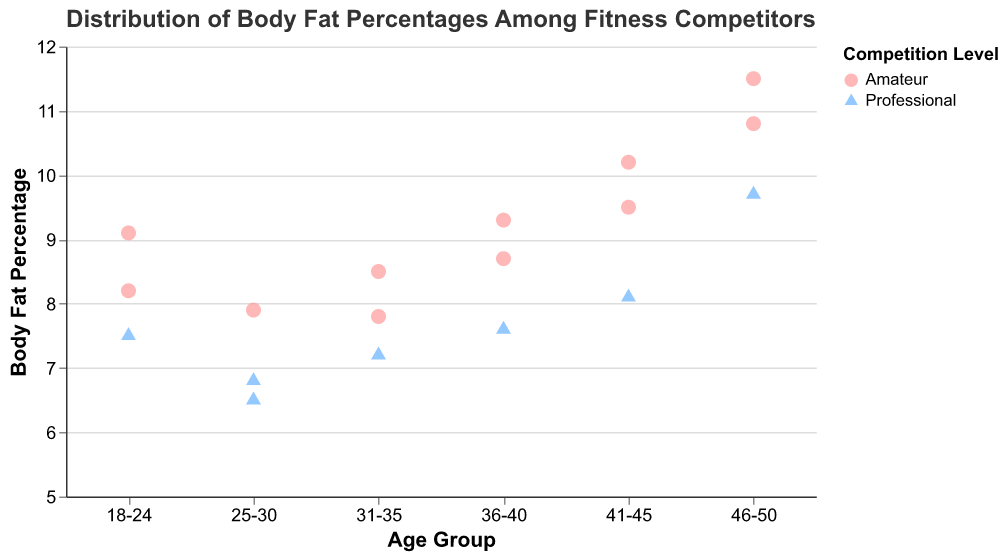What is the title of the figure? The title is usually at the top of the figure and typically in larger font size. Here, it is "Distribution of Body Fat Percentages Among Fitness Competitors."
Answer: Distribution of Body Fat Percentages Among Fitness Competitors What are the age groups present in the figure? The x-axis represents age groups. We can see the labels: "18-24", "25-30", "31-35", "36-40", "41-45", and "46-50".
Answer: 18-24, 25-30, 31-35, 36-40, 41-45, 46-50 Which age group has the lowest body fat percentage for professional competitors? We look for the lowest y-value within each age group where the color and shape indicate professional competitors. The lowest is in the 25-30 age group with 6.5%.
Answer: 25-30 How does the body fat percentage vary between amateur and professional competitors in the 41-45 age group? For amateur competitors, the percentages are 9.5 and 10.2. For professionals, it is 8.1. By comparison, professionals tend to have lower body fat percentages.
Answer: Professionals have lower body fat percentages What is the average body fat percentage for the 18-24 age group? Body fat percentages in the 18-24 age group are 8.2, 7.5, and 9.1. Calculate the average: (8.2 + 7.5 + 9.1) / 3.
Answer: 8.26 Which age group has the highest maximum body fat percentage? We check the maximum values on the y-axis for each age group. The 46-50 group has the highest maximum with 11.5%.
Answer: 46-50 Is there any age group where all competitors have body fat percentages below 9? We cross-check all y-values for each age group. The 25-30 age group has all values below 9 (6.5, 6.8, 7.9).
Answer: 25-30 What is the range of body fat percentages for the 36-40 age group? The body fat percentages in the 36-40 age group are 7.6, 8.7, and 9.3. The range is calculated as the maximum value minus the minimum value: 9.3 - 7.6.
Answer: 1.7 Between amateur and professional competitors in the 31-35 age group, who shows more variation in body fat percentage? In this age group, amateurs have body fat percentages of 8.5 and 7.8. Professionals have 7.2. The amateur range is 8.5 - 7.8 = 0.7, and professionals' variation isn't applicable with a single data point. Thus, more variation is in the amateur group.
Answer: Amateurs What is the median body fat percentage for amateurs in the 46-50 age group? The body fat percentages for amateurs in the 46-50 age group are 10.8, 11.5, and 9.7. The median is the middle value when ordered: 9.7, 10.8, 11.5.
Answer: 10.8 